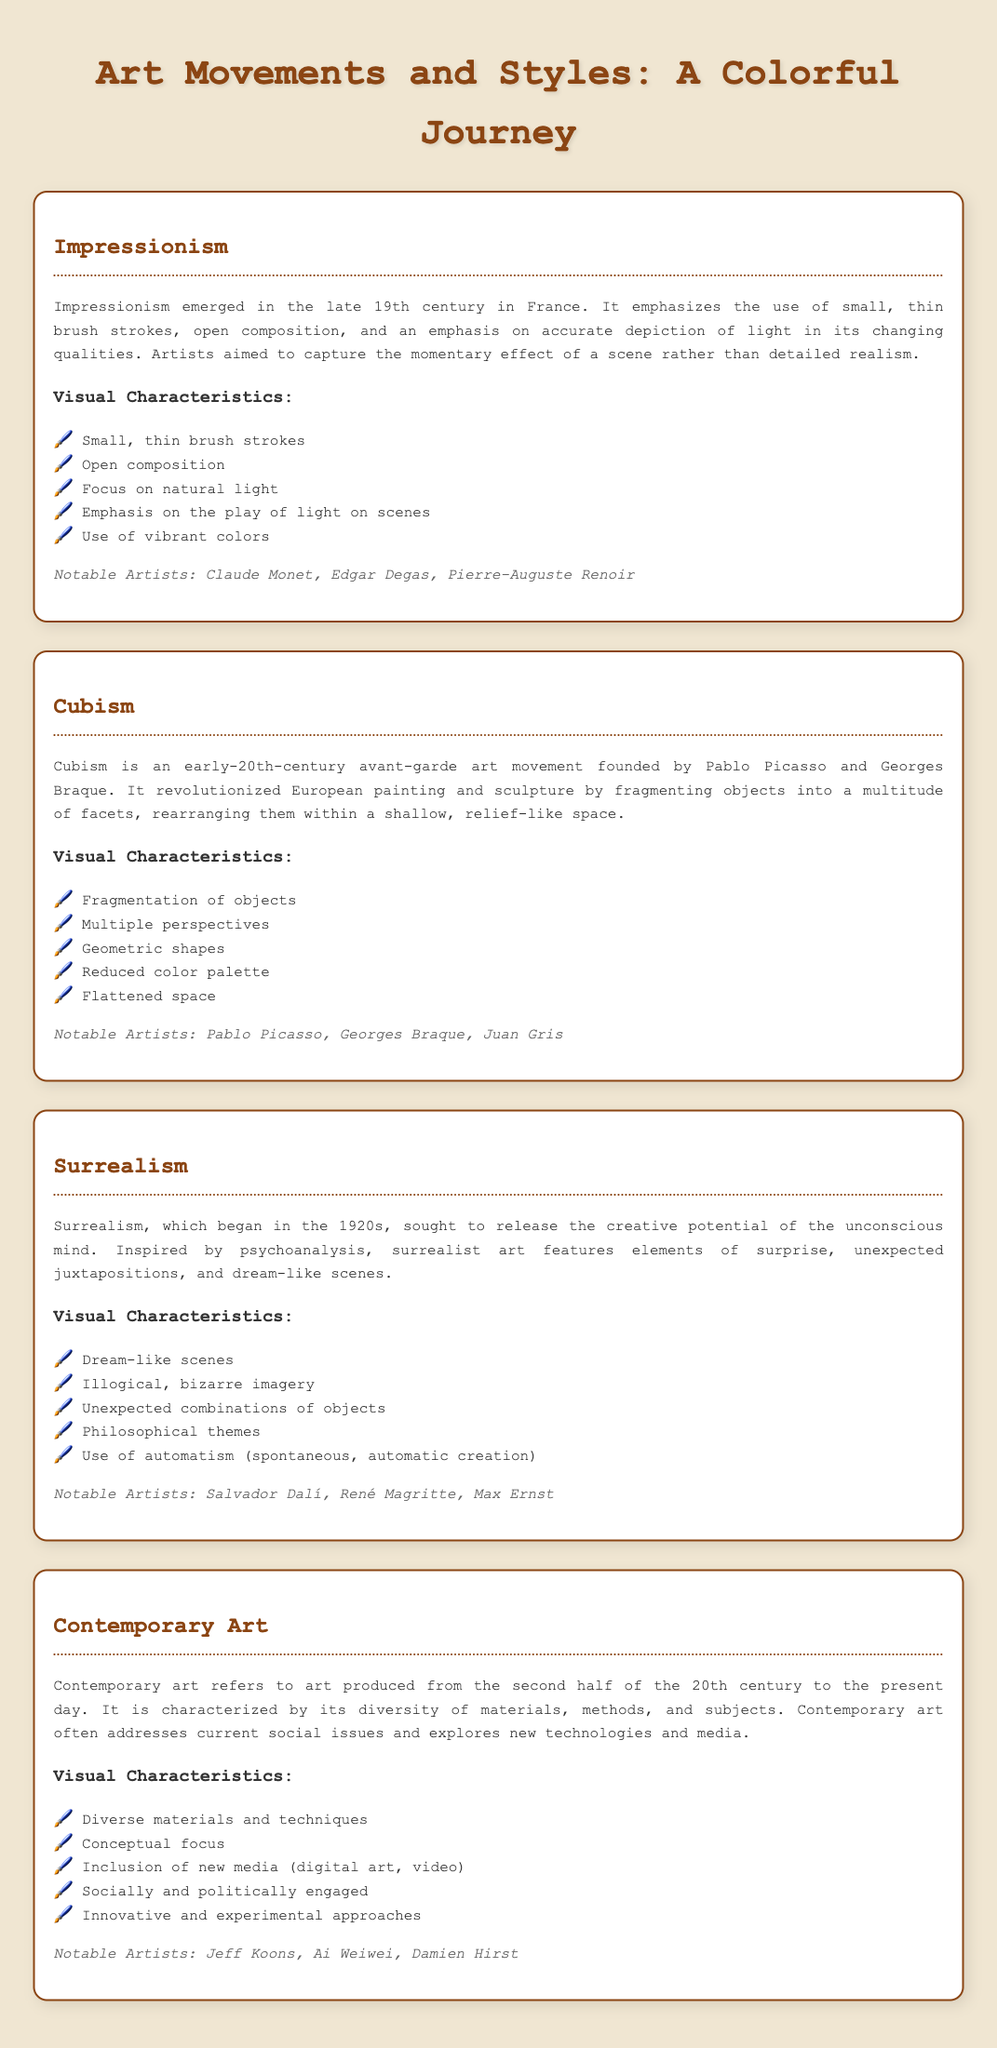What movement emphasizes the use of small, thin brush strokes? Impressionism is characterized by the use of small, thin brush strokes to capture light and color.
Answer: Impressionism Who are three notable artists of Cubism? The document lists Pablo Picasso, Georges Braque, and Juan Gris as notable artists of Cubism.
Answer: Pablo Picasso, Georges Braque, Juan Gris What year did Surrealism begin? According to the glossary, Surrealism began in the 1920s.
Answer: 1920s Which art movement focuses on dream-like scenes and unexpected combinations? Surrealism is known for its dream-like scenes and unexpected juxtapositions.
Answer: Surrealism What characterizes Contemporary Art? The glossary states that Contemporary Art is characterized by its diversity of materials, methods, and subjects.
Answer: Diversity of materials, methods, and subjects What type of focus is emphasized in Contemporary Art? The document notes a conceptual focus in Contemporary Art.
Answer: Conceptual focus Which art movement features geometric shapes and multiple perspectives? Cubism is defined by its use of geometric shapes and multiple perspectives.
Answer: Cubism Name one notable artist associated with Impressionism. The glossary mentions Claude Monet as a notable artist of Impressionism.
Answer: Claude Monet What visual characteristic is common in both Impressionism and Cubism? Both movements incorporate the use of vibrant colors as noted in the descriptions.
Answer: Vibrant colors 